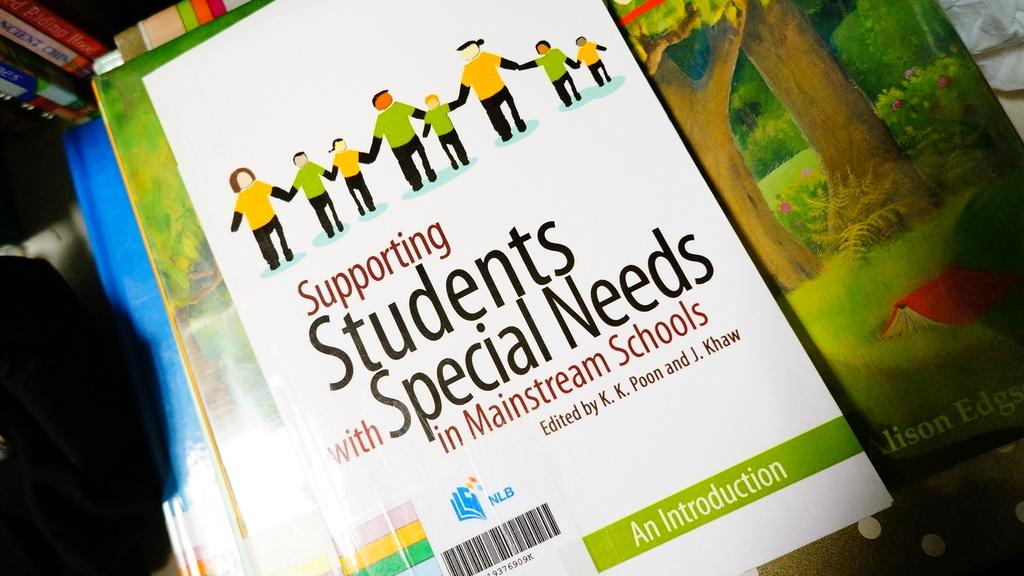<image>
Relay a brief, clear account of the picture shown. A book is entitled "Supporting Students with Special Needs in Mainstream Schools." 